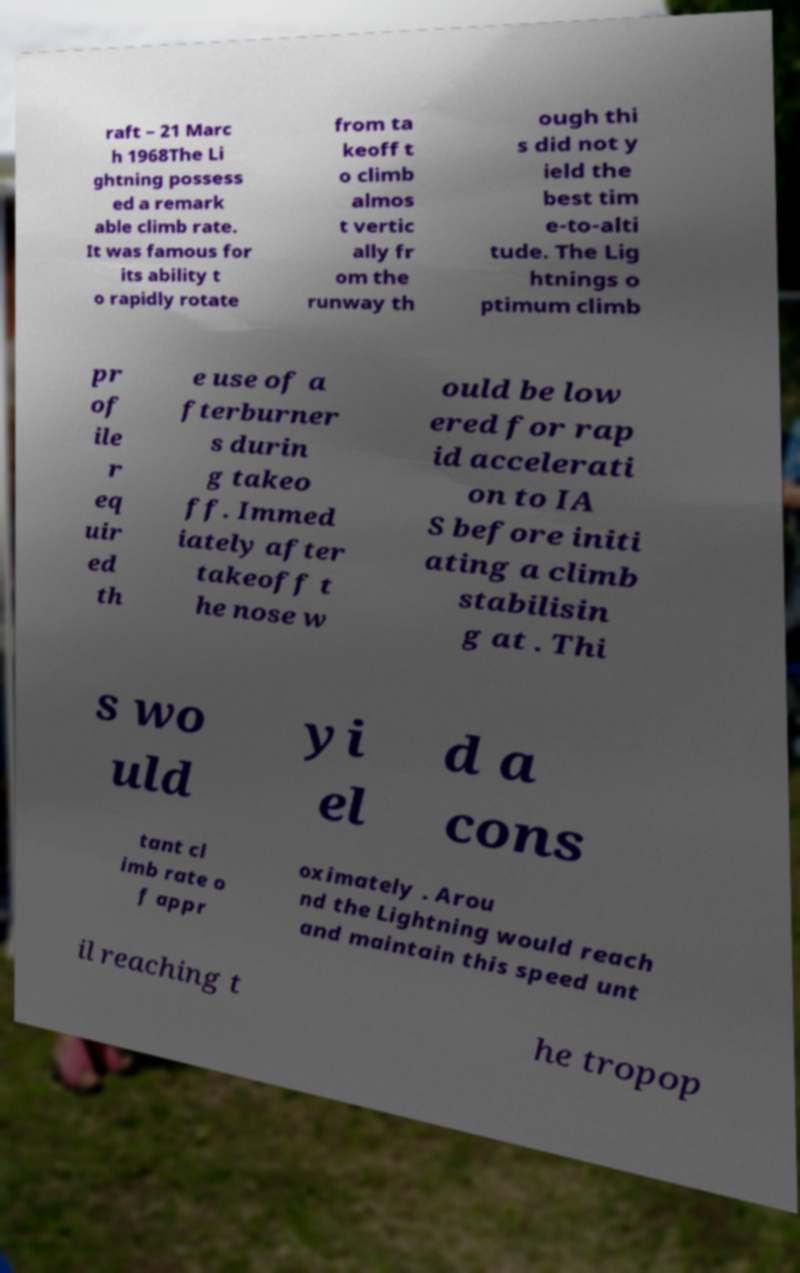There's text embedded in this image that I need extracted. Can you transcribe it verbatim? raft – 21 Marc h 1968The Li ghtning possess ed a remark able climb rate. It was famous for its ability t o rapidly rotate from ta keoff t o climb almos t vertic ally fr om the runway th ough thi s did not y ield the best tim e-to-alti tude. The Lig htnings o ptimum climb pr of ile r eq uir ed th e use of a fterburner s durin g takeo ff. Immed iately after takeoff t he nose w ould be low ered for rap id accelerati on to IA S before initi ating a climb stabilisin g at . Thi s wo uld yi el d a cons tant cl imb rate o f appr oximately . Arou nd the Lightning would reach and maintain this speed unt il reaching t he tropop 